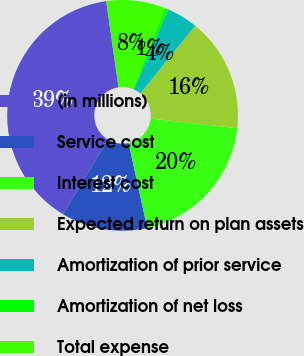<chart> <loc_0><loc_0><loc_500><loc_500><pie_chart><fcel>(in millions)<fcel>Service cost<fcel>Interest cost<fcel>Expected return on plan assets<fcel>Amortization of prior service<fcel>Amortization of net loss<fcel>Total expense<nl><fcel>39.09%<fcel>12.08%<fcel>19.8%<fcel>15.94%<fcel>4.36%<fcel>0.51%<fcel>8.22%<nl></chart> 